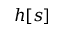<formula> <loc_0><loc_0><loc_500><loc_500>h [ s ]</formula> 